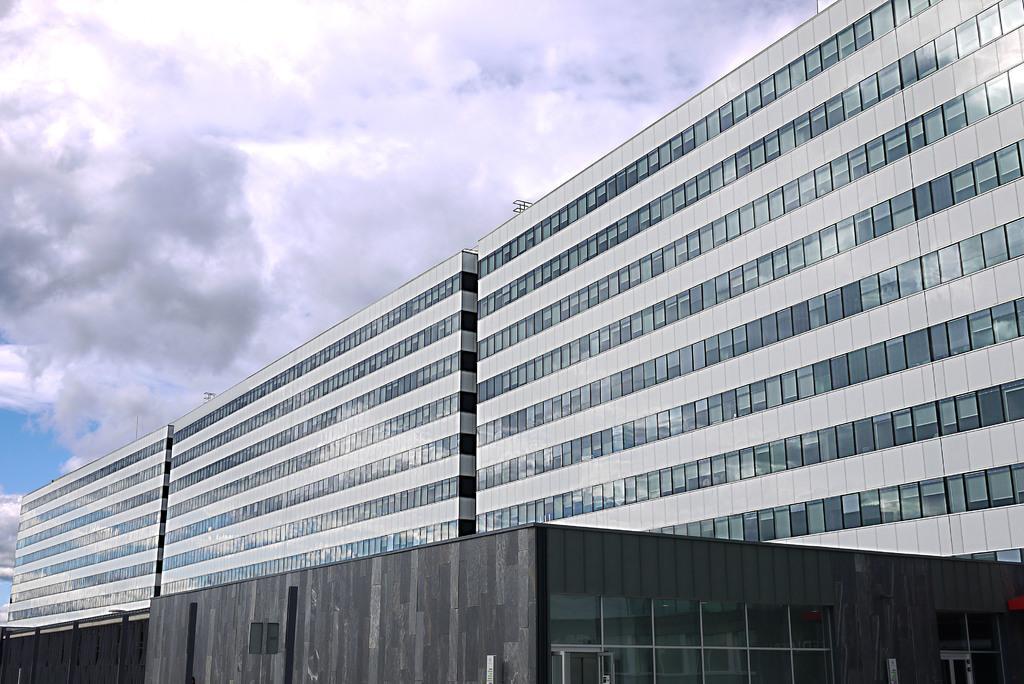Can you describe this image briefly? In this image I can see few buildings in gray and black color, background the sky is in white and blue color. 